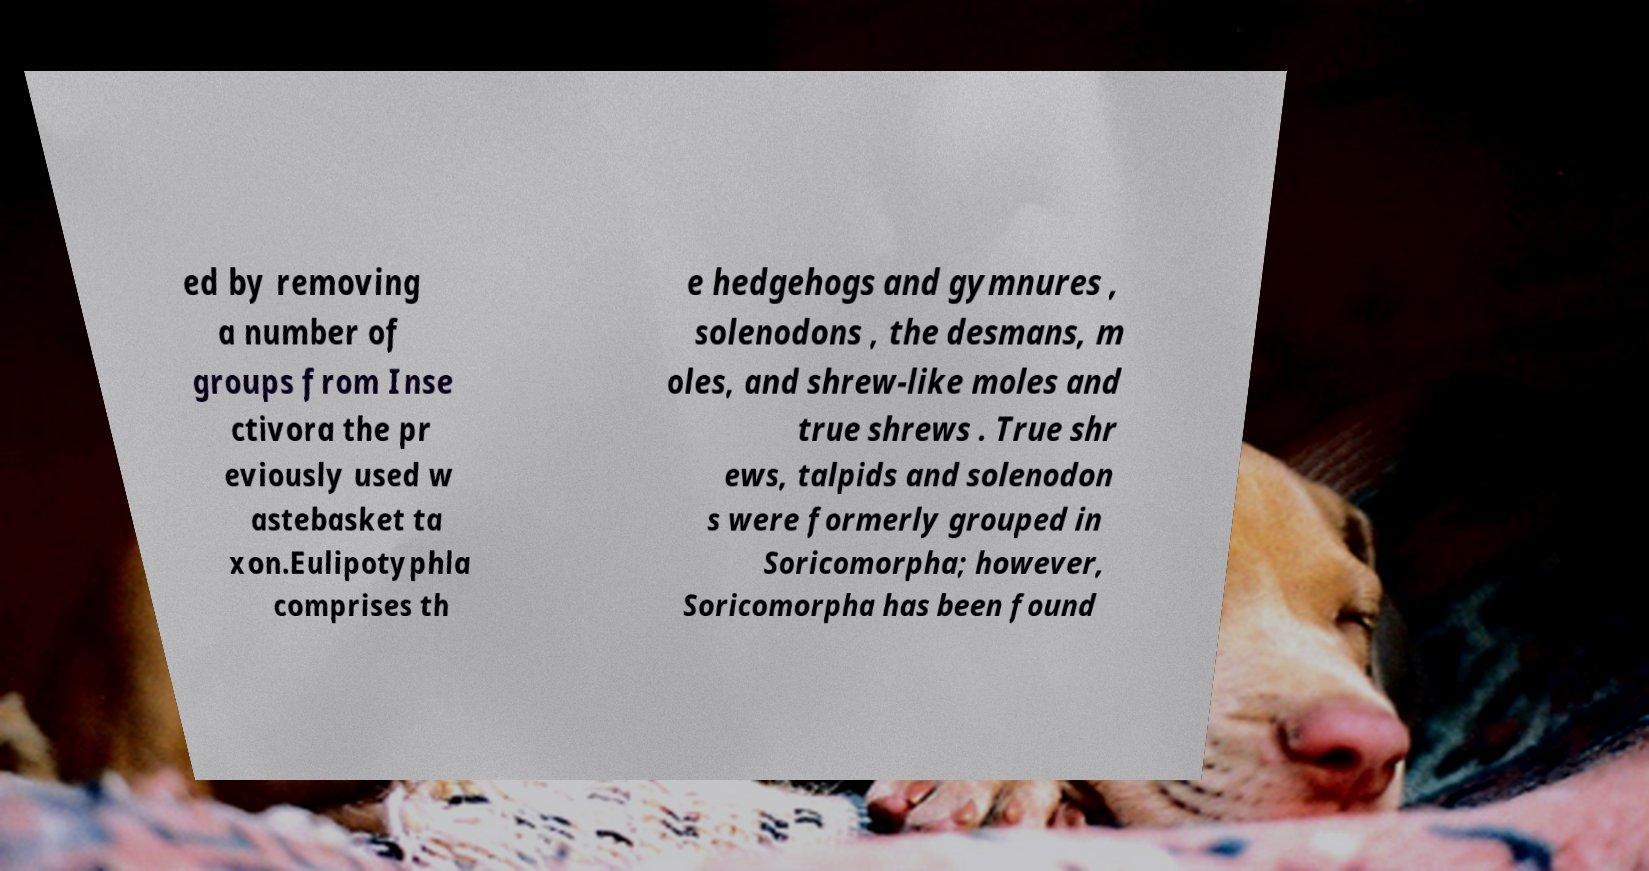There's text embedded in this image that I need extracted. Can you transcribe it verbatim? ed by removing a number of groups from Inse ctivora the pr eviously used w astebasket ta xon.Eulipotyphla comprises th e hedgehogs and gymnures , solenodons , the desmans, m oles, and shrew-like moles and true shrews . True shr ews, talpids and solenodon s were formerly grouped in Soricomorpha; however, Soricomorpha has been found 